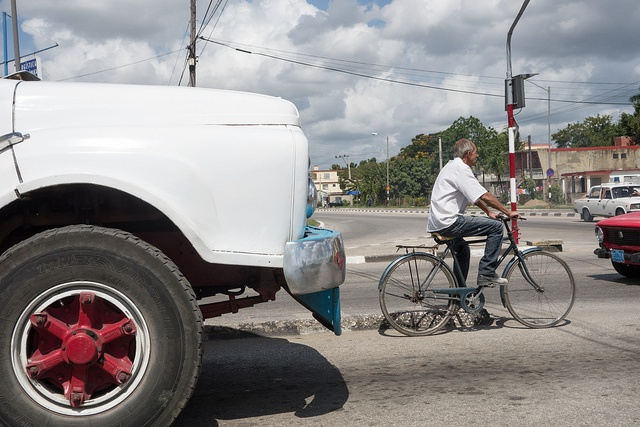Describe the objects in this image and their specific colors. I can see truck in gray, white, black, and darkgray tones, bicycle in gray, darkgray, and black tones, people in gray, black, lightgray, and darkgray tones, car in gray, black, maroon, and salmon tones, and car in gray, darkgray, lightgray, and black tones in this image. 